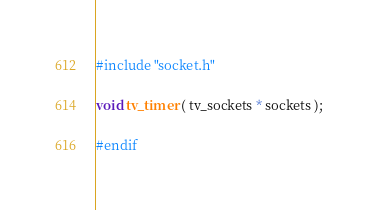Convert code to text. <code><loc_0><loc_0><loc_500><loc_500><_C_>
#include "socket.h"

void tv_timer ( tv_sockets * sockets );

#endif
</code> 